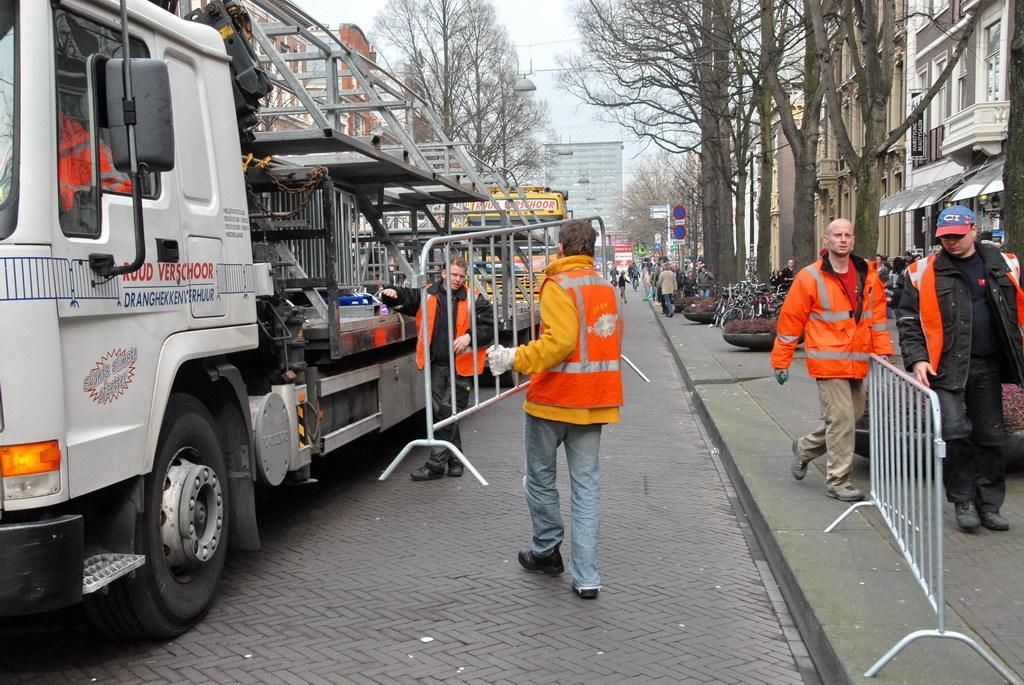Describe this image in one or two sentences. In this picture we can see vehicles, people on the ground, here we can see buildings, trees and some objects. 